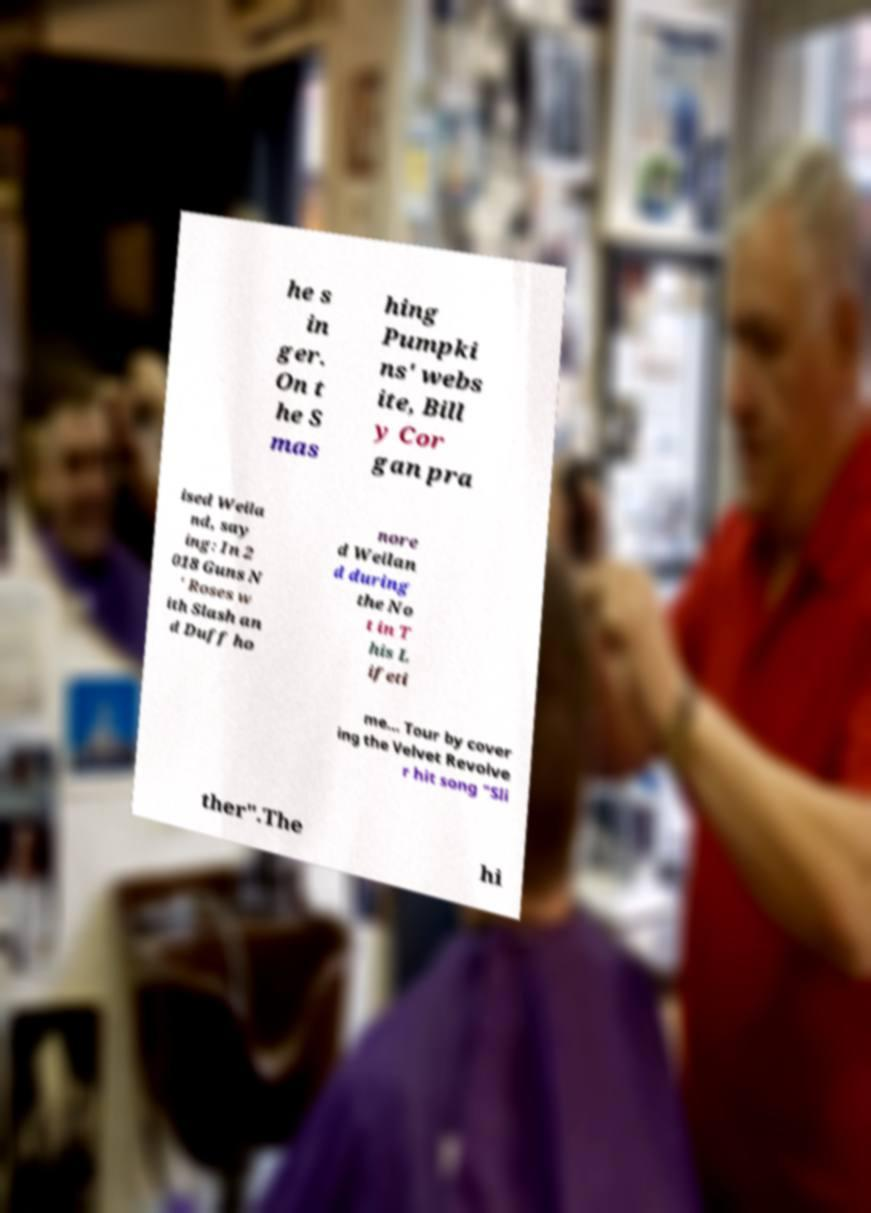I need the written content from this picture converted into text. Can you do that? he s in ger. On t he S mas hing Pumpki ns' webs ite, Bill y Cor gan pra ised Weila nd, say ing: In 2 018 Guns N ' Roses w ith Slash an d Duff ho nore d Weilan d during the No t in T his L ifeti me... Tour by cover ing the Velvet Revolve r hit song "Sli ther".The hi 